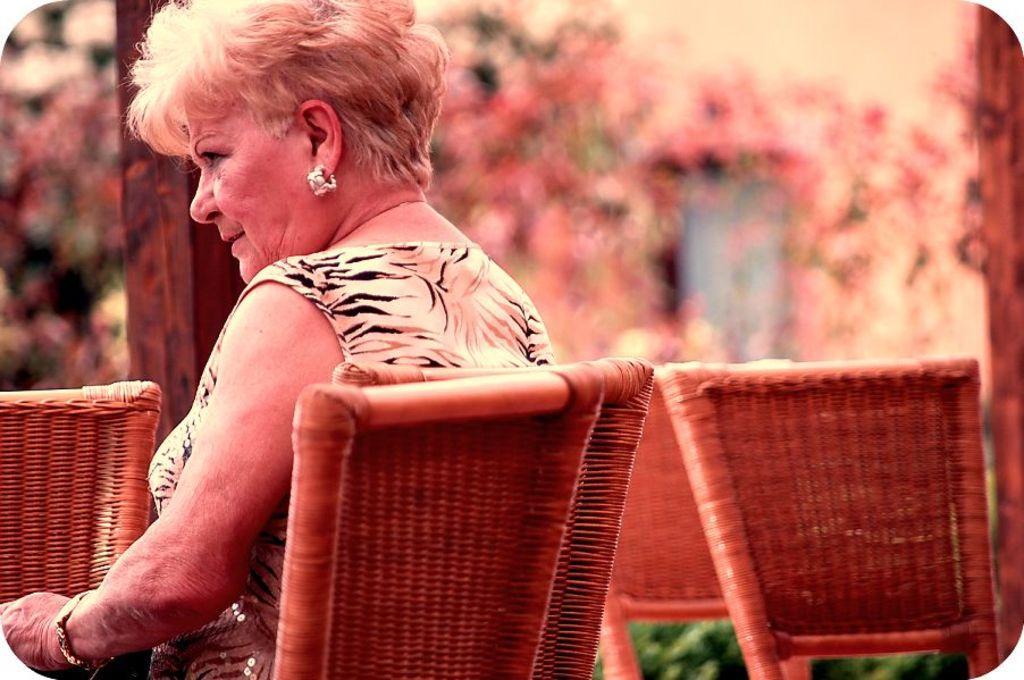Please provide a concise description of this image. In this picture I can see a woman sitting on the chair, there are chairs, and there is blur background. 